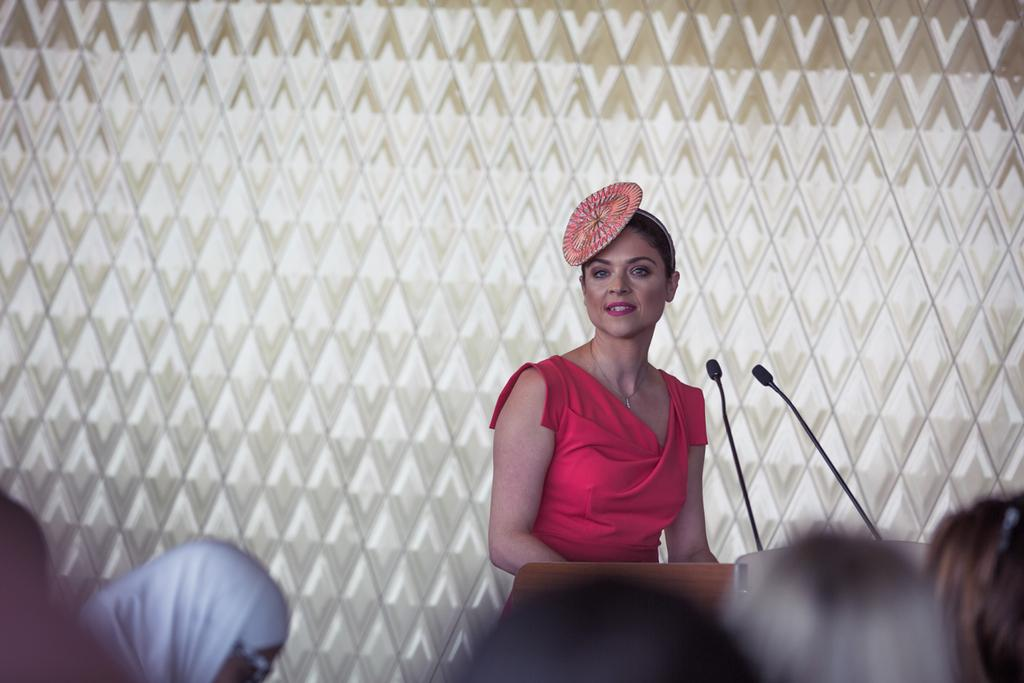Who is the main subject in the image? There is a woman in the image. What is the woman wearing? The woman is wearing a red dress. Where is the woman standing? The woman is standing in front of a dias. How many people are in front of the woman? There are many people in front of the woman. What can be seen behind the woman? There is a wall behind the woman. Can you see any rings on the woman's fingers in the image? There is no information about rings on the woman's fingers in the provided facts, so we cannot determine if any rings are visible in the image. 